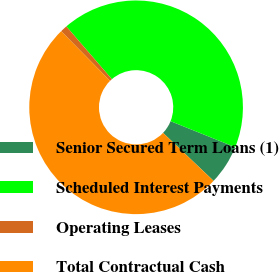<chart> <loc_0><loc_0><loc_500><loc_500><pie_chart><fcel>Senior Secured Term Loans (1)<fcel>Scheduled Interest Payments<fcel>Operating Leases<fcel>Total Contractual Cash<nl><fcel>6.0%<fcel>42.42%<fcel>1.05%<fcel>50.54%<nl></chart> 